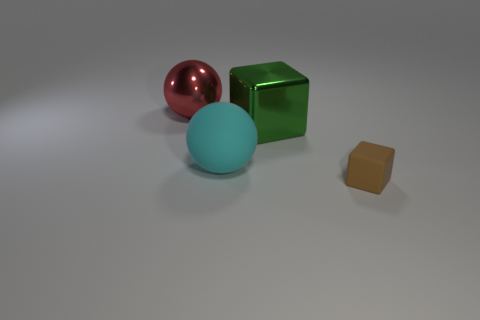Does the green metal block have the same size as the cyan thing?
Offer a terse response. Yes. Is there a big red ball that is behind the large object that is behind the cube that is behind the rubber block?
Your answer should be compact. No. There is another tiny thing that is the same shape as the green metal thing; what material is it?
Your response must be concise. Rubber. The matte object that is on the right side of the big green block is what color?
Give a very brief answer. Brown. The green thing is what size?
Provide a succinct answer. Large. Is the size of the green metal object the same as the rubber thing that is on the right side of the big cyan rubber sphere?
Provide a short and direct response. No. What is the color of the large shiny thing that is to the right of the big ball in front of the big thing that is left of the large matte thing?
Provide a short and direct response. Green. Does the cube that is right of the metal cube have the same material as the green object?
Provide a succinct answer. No. How many other things are the same material as the brown thing?
Offer a terse response. 1. There is a green block that is the same size as the matte sphere; what is it made of?
Your answer should be very brief. Metal. 